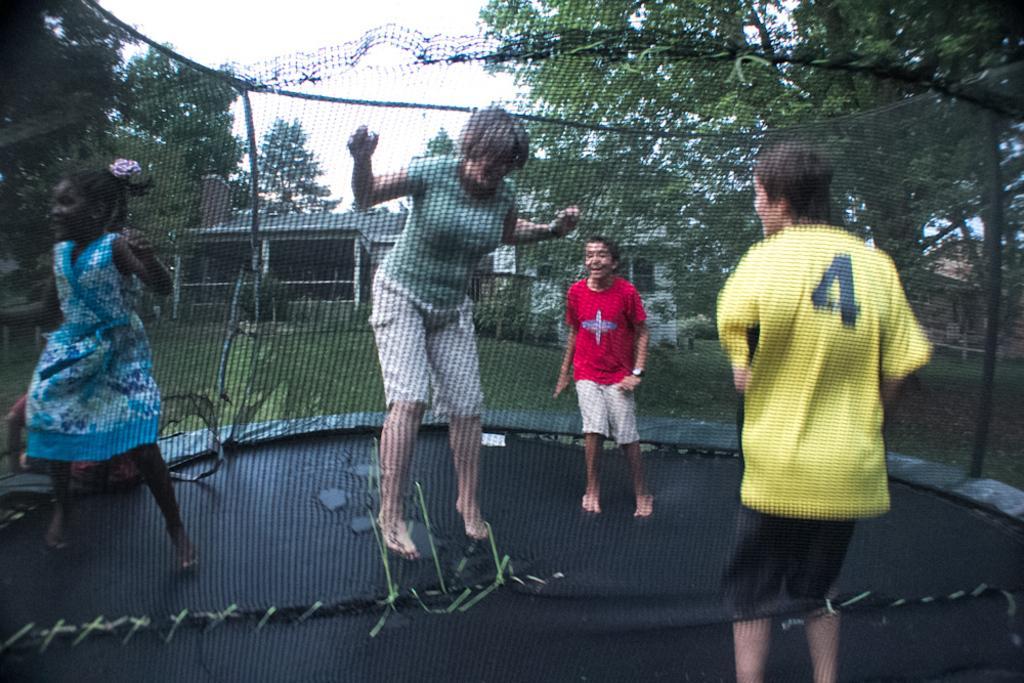In one or two sentences, can you explain what this image depicts? In this image, we can see a net fence. On the net fence, we can see four people are jumping on the mat. In the background, we can see some trees, house, electrical wires. At the top, we can see a sky. 